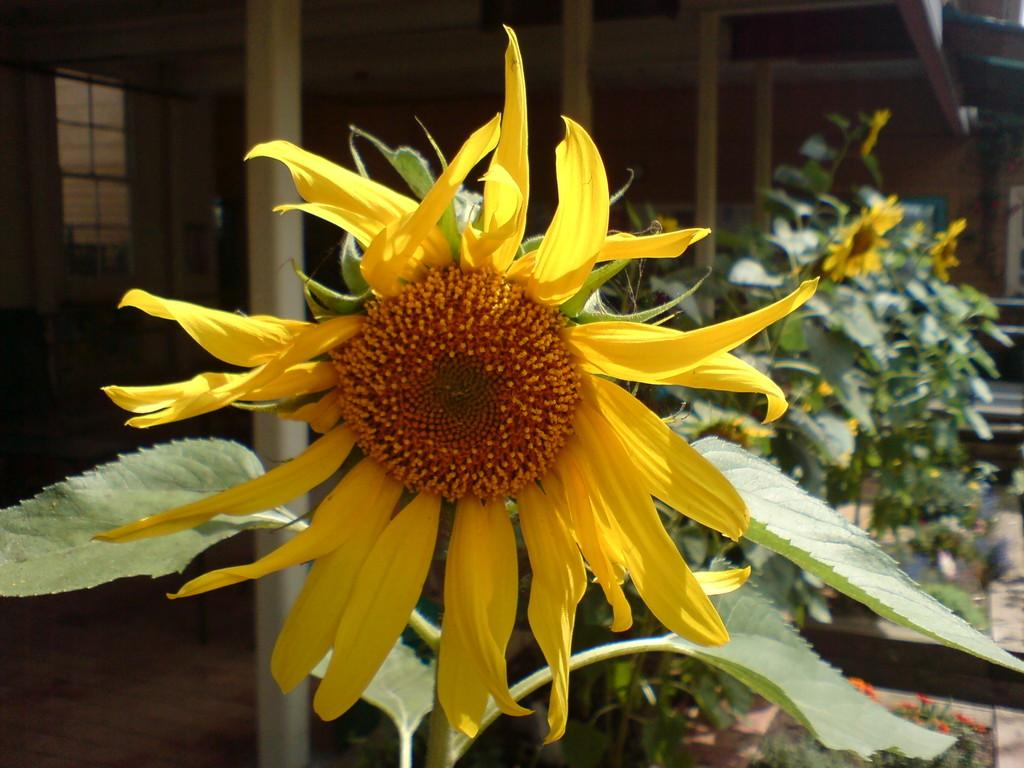What colors are the flowers in the image? The flowers in the image are yellow and orange in color. What color are the leaves in the image? The leaves are green in color. What type of structure is present in the image? There is a building in the image. What material are the poles in the image made of? The poles are made of wood. What feature allows light to enter the building in the image? There are windows in the image. What type of bead is being used to decorate the car in the image? There is no car present in the image, so there is no bead to be used for decoration. 